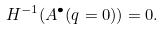<formula> <loc_0><loc_0><loc_500><loc_500>H ^ { - 1 } ( A ^ { \bullet } ( q = 0 ) ) = 0 .</formula> 